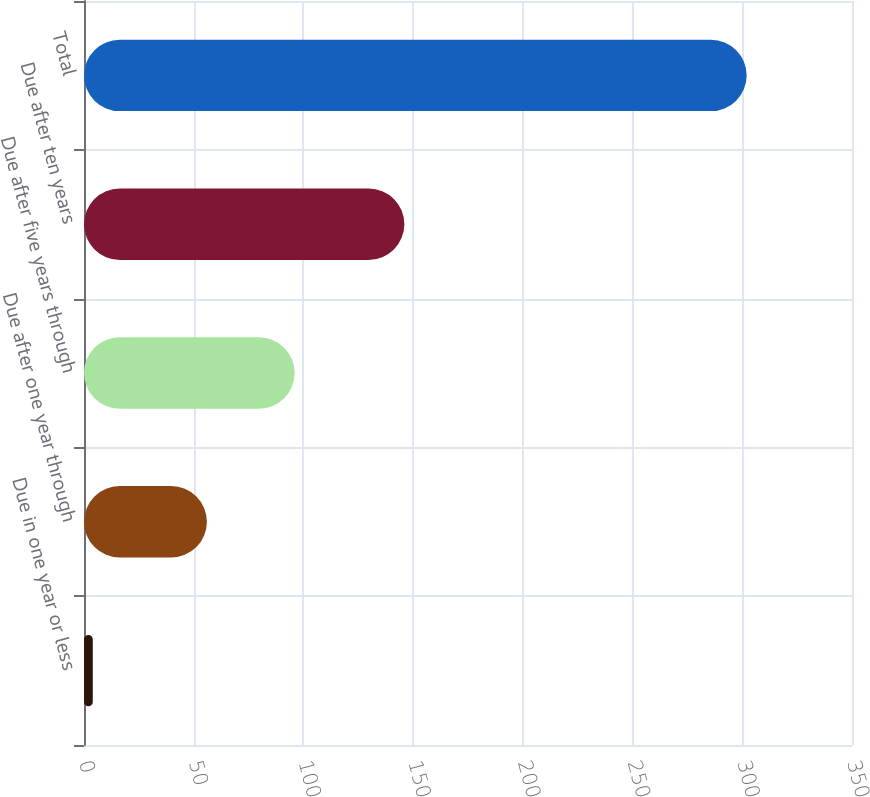Convert chart to OTSL. <chart><loc_0><loc_0><loc_500><loc_500><bar_chart><fcel>Due in one year or less<fcel>Due after one year through<fcel>Due after five years through<fcel>Due after ten years<fcel>Total<nl><fcel>4<fcel>56<fcel>96<fcel>146<fcel>302<nl></chart> 